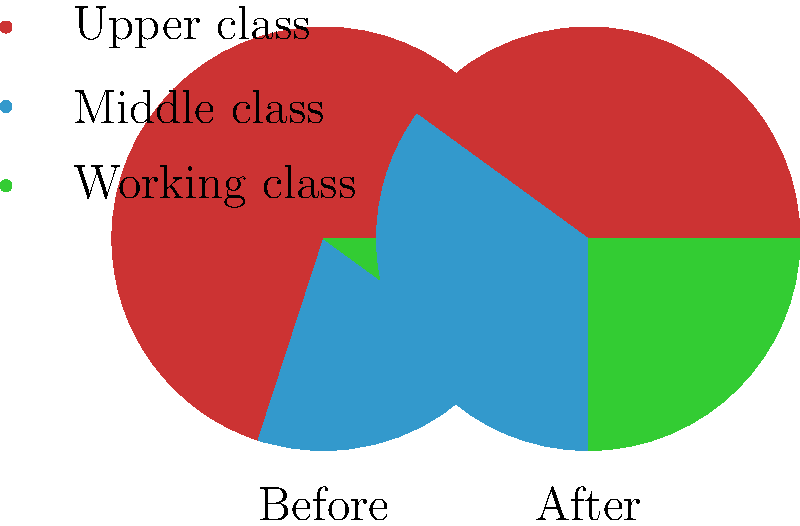Analyze the pie charts representing wealth distribution before and after a socialist revolution. Which class experienced the most significant relative increase in wealth share, and how does this align with Marxist theory on class struggle and socialist transformation? To analyze this question, let's follow these steps:

1. Identify the wealth distribution before the revolution:
   Upper class: 70%
   Middle class: 20%
   Working class: 10%

2. Identify the wealth distribution after the revolution:
   Upper class: 40%
   Middle class: 35%
   Working class: 25%

3. Calculate the relative change for each class:
   Upper class: (40% - 70%) / 70% = -42.9% decrease
   Middle class: (35% - 20%) / 20% = 75% increase
   Working class: (25% - 10%) / 10% = 150% increase

4. Determine which class experienced the most significant relative increase:
   The working class had the largest relative increase at 150%.

5. Analyze this in the context of Marxist theory:
   a) Class struggle: Marx argued that history is driven by class conflict, with the working class (proletariat) struggling against the ruling class (bourgeoisie).
   b) Socialist transformation: The goal of socialism is to transfer the means of production from the bourgeoisie to the proletariat, leading to a more equitable distribution of wealth.
   c) Dictatorship of the proletariat: In the transition to socialism, the working class is expected to take control of the state and economy.

6. Alignment with Marxist theory:
   The significant increase in the working class's share of wealth (150%) aligns with Marxist theory, as it demonstrates:
   - A reduction in class inequality
   - The empowerment of the proletariat
   - A step towards the socialist goal of a classless society

However, it's important to note that while the working class gained the most relatively, there is still inequality present, which would be seen as an ongoing process of socialist transformation rather than a final state.
Answer: The working class, with a 150% relative increase, aligning with Marxist theory on proletariat empowerment and reduction of class inequality. 